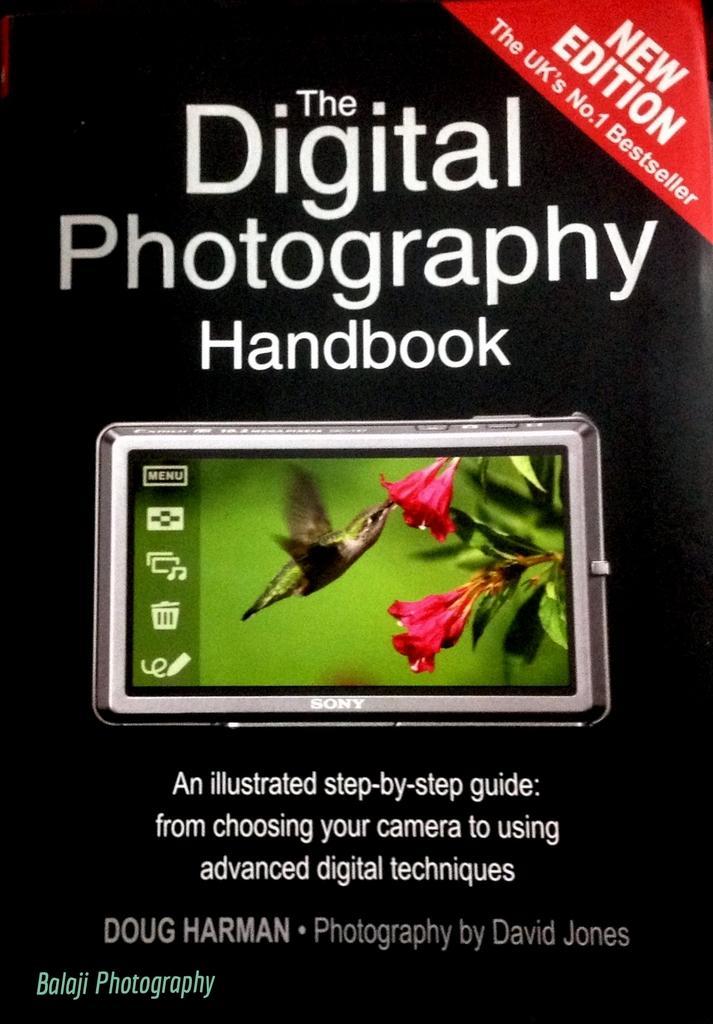Can you describe this image briefly? It is the cover page of the book. In this image we can see that there is a bird which is eating the pollen grains which are in the flower. 